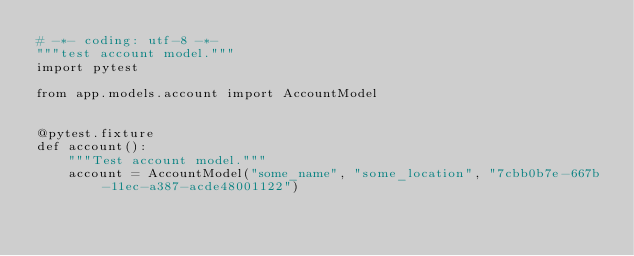Convert code to text. <code><loc_0><loc_0><loc_500><loc_500><_Python_># -*- coding: utf-8 -*-
"""test account model."""
import pytest

from app.models.account import AccountModel


@pytest.fixture
def account():
    """Test account model."""
    account = AccountModel("some_name", "some_location", "7cbb0b7e-667b-11ec-a387-acde48001122")
    </code> 